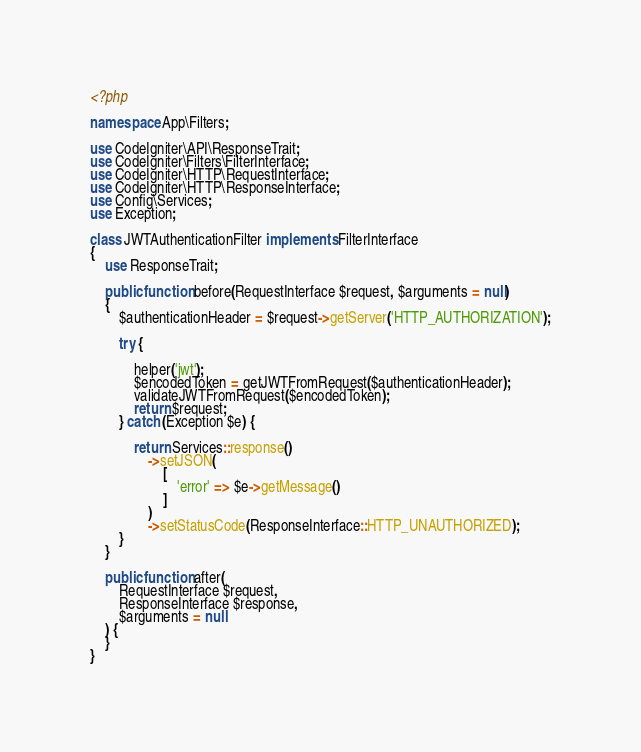<code> <loc_0><loc_0><loc_500><loc_500><_PHP_><?php

namespace App\Filters;

use CodeIgniter\API\ResponseTrait;
use CodeIgniter\Filters\FilterInterface;
use CodeIgniter\HTTP\RequestInterface;
use CodeIgniter\HTTP\ResponseInterface;
use Config\Services;
use Exception;

class JWTAuthenticationFilter implements FilterInterface
{
    use ResponseTrait;

    public function before(RequestInterface $request, $arguments = null)
    {
        $authenticationHeader = $request->getServer('HTTP_AUTHORIZATION');

        try {

            helper('jwt');
            $encodedToken = getJWTFromRequest($authenticationHeader);
            validateJWTFromRequest($encodedToken);
            return $request;
        } catch (Exception $e) {

            return Services::response()
                ->setJSON(
                    [
                        'error' => $e->getMessage()
                    ]
                )
                ->setStatusCode(ResponseInterface::HTTP_UNAUTHORIZED);
        }
    }

    public function after(
        RequestInterface $request,
        ResponseInterface $response,
        $arguments = null
    ) {
    }
}
</code> 